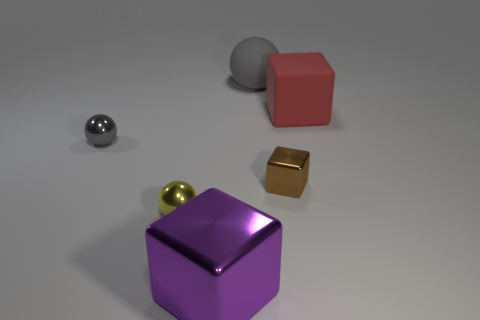Subtract all gray balls. How many balls are left? 1 Subtract all gray spheres. How many spheres are left? 1 Subtract all big red matte objects. Subtract all metal spheres. How many objects are left? 3 Add 3 red blocks. How many red blocks are left? 4 Add 5 big green metallic blocks. How many big green metallic blocks exist? 5 Add 1 red spheres. How many objects exist? 7 Subtract 0 cyan blocks. How many objects are left? 6 Subtract 1 cubes. How many cubes are left? 2 Subtract all green balls. Subtract all green cylinders. How many balls are left? 3 Subtract all yellow spheres. How many cyan blocks are left? 0 